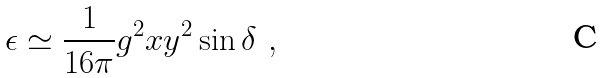Convert formula to latex. <formula><loc_0><loc_0><loc_500><loc_500>\epsilon \simeq \frac { 1 } { 1 6 \pi } g ^ { 2 } x y ^ { 2 } \sin \delta \ ,</formula> 